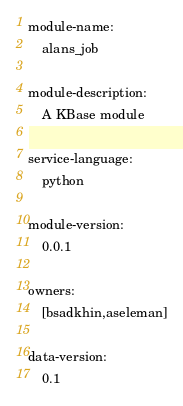Convert code to text. <code><loc_0><loc_0><loc_500><loc_500><_YAML_>module-name:
    alans_job

module-description:
    A KBase module

service-language:
    python

module-version:
    0.0.1

owners:
    [bsadkhin,aseleman]

data-version:
    0.1
</code> 